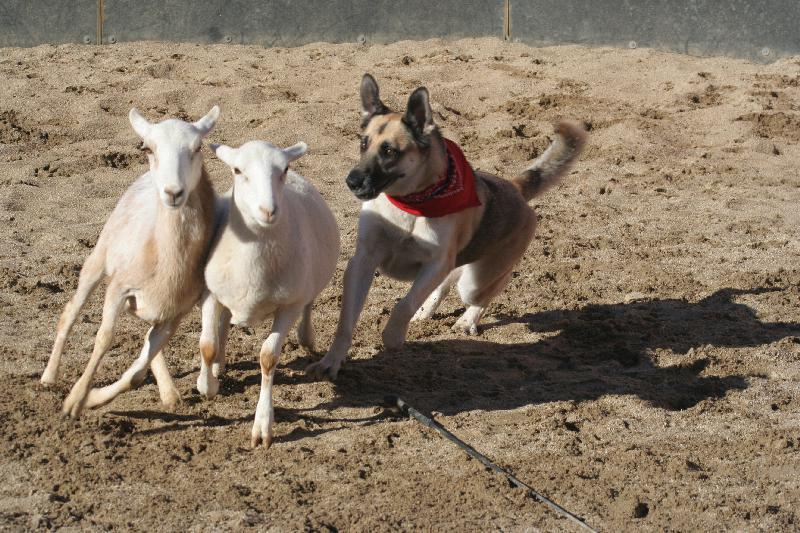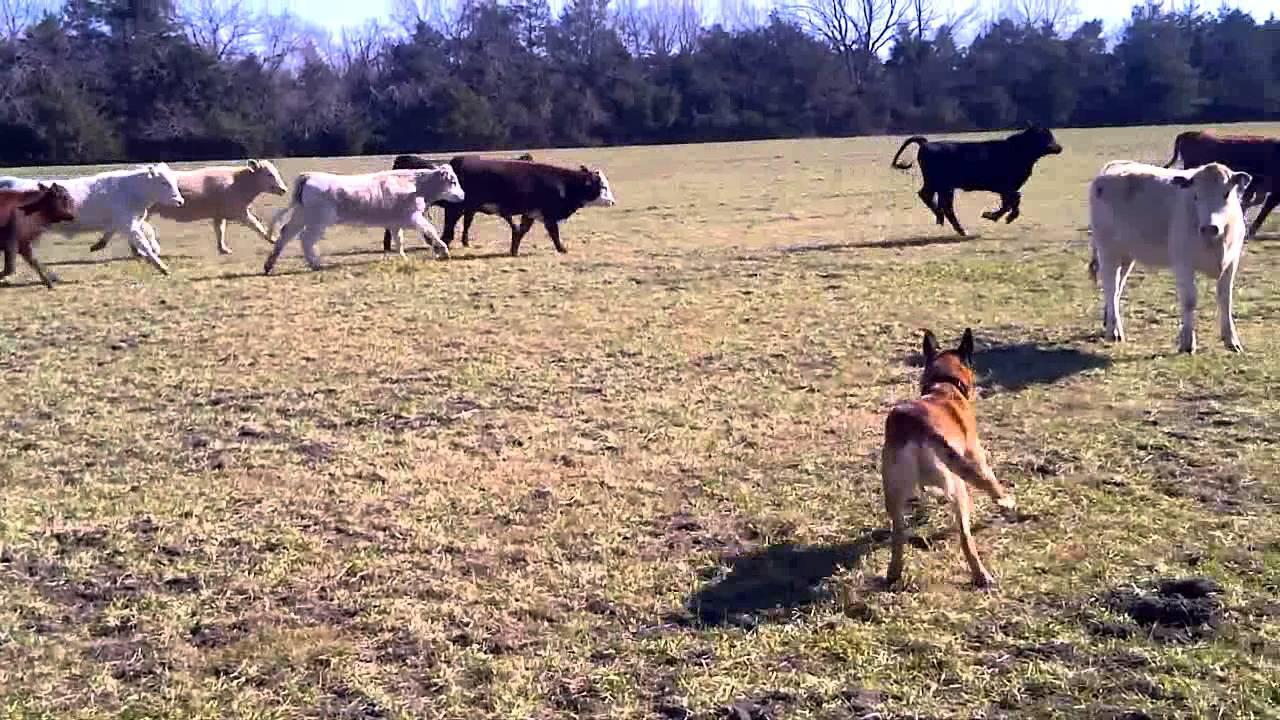The first image is the image on the left, the second image is the image on the right. For the images shown, is this caption "There are no more than two animals in the image on the right." true? Answer yes or no. No. 